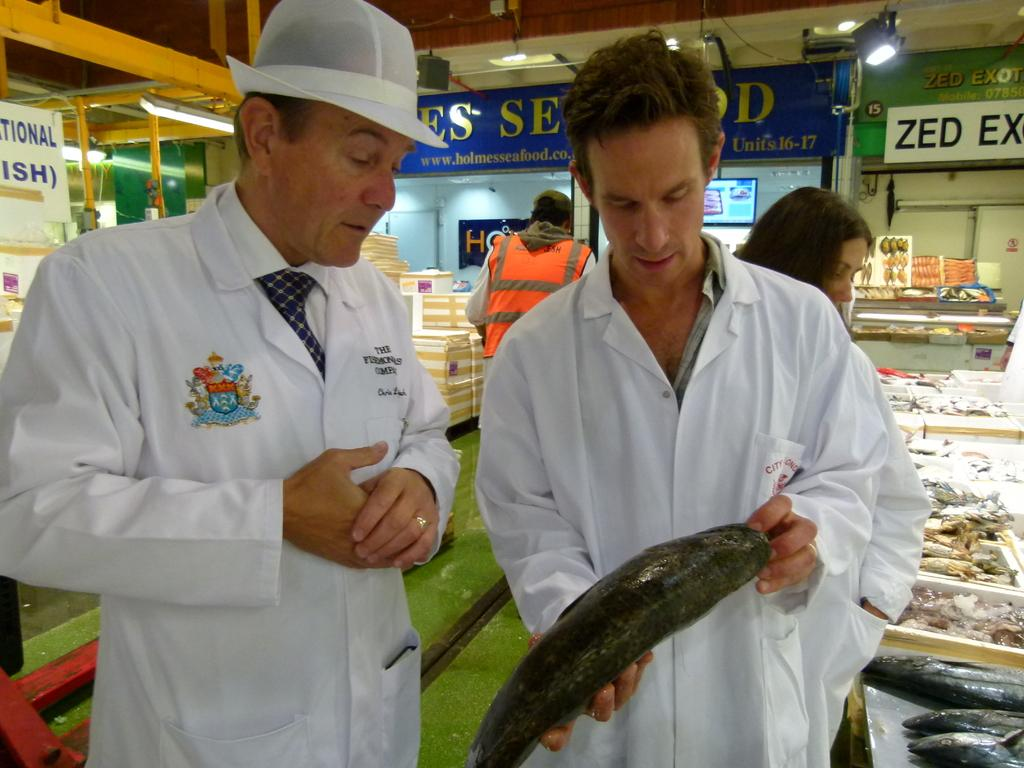Provide a one-sentence caption for the provided image. A man holding a fish, and a sign that says zed ex on it. 